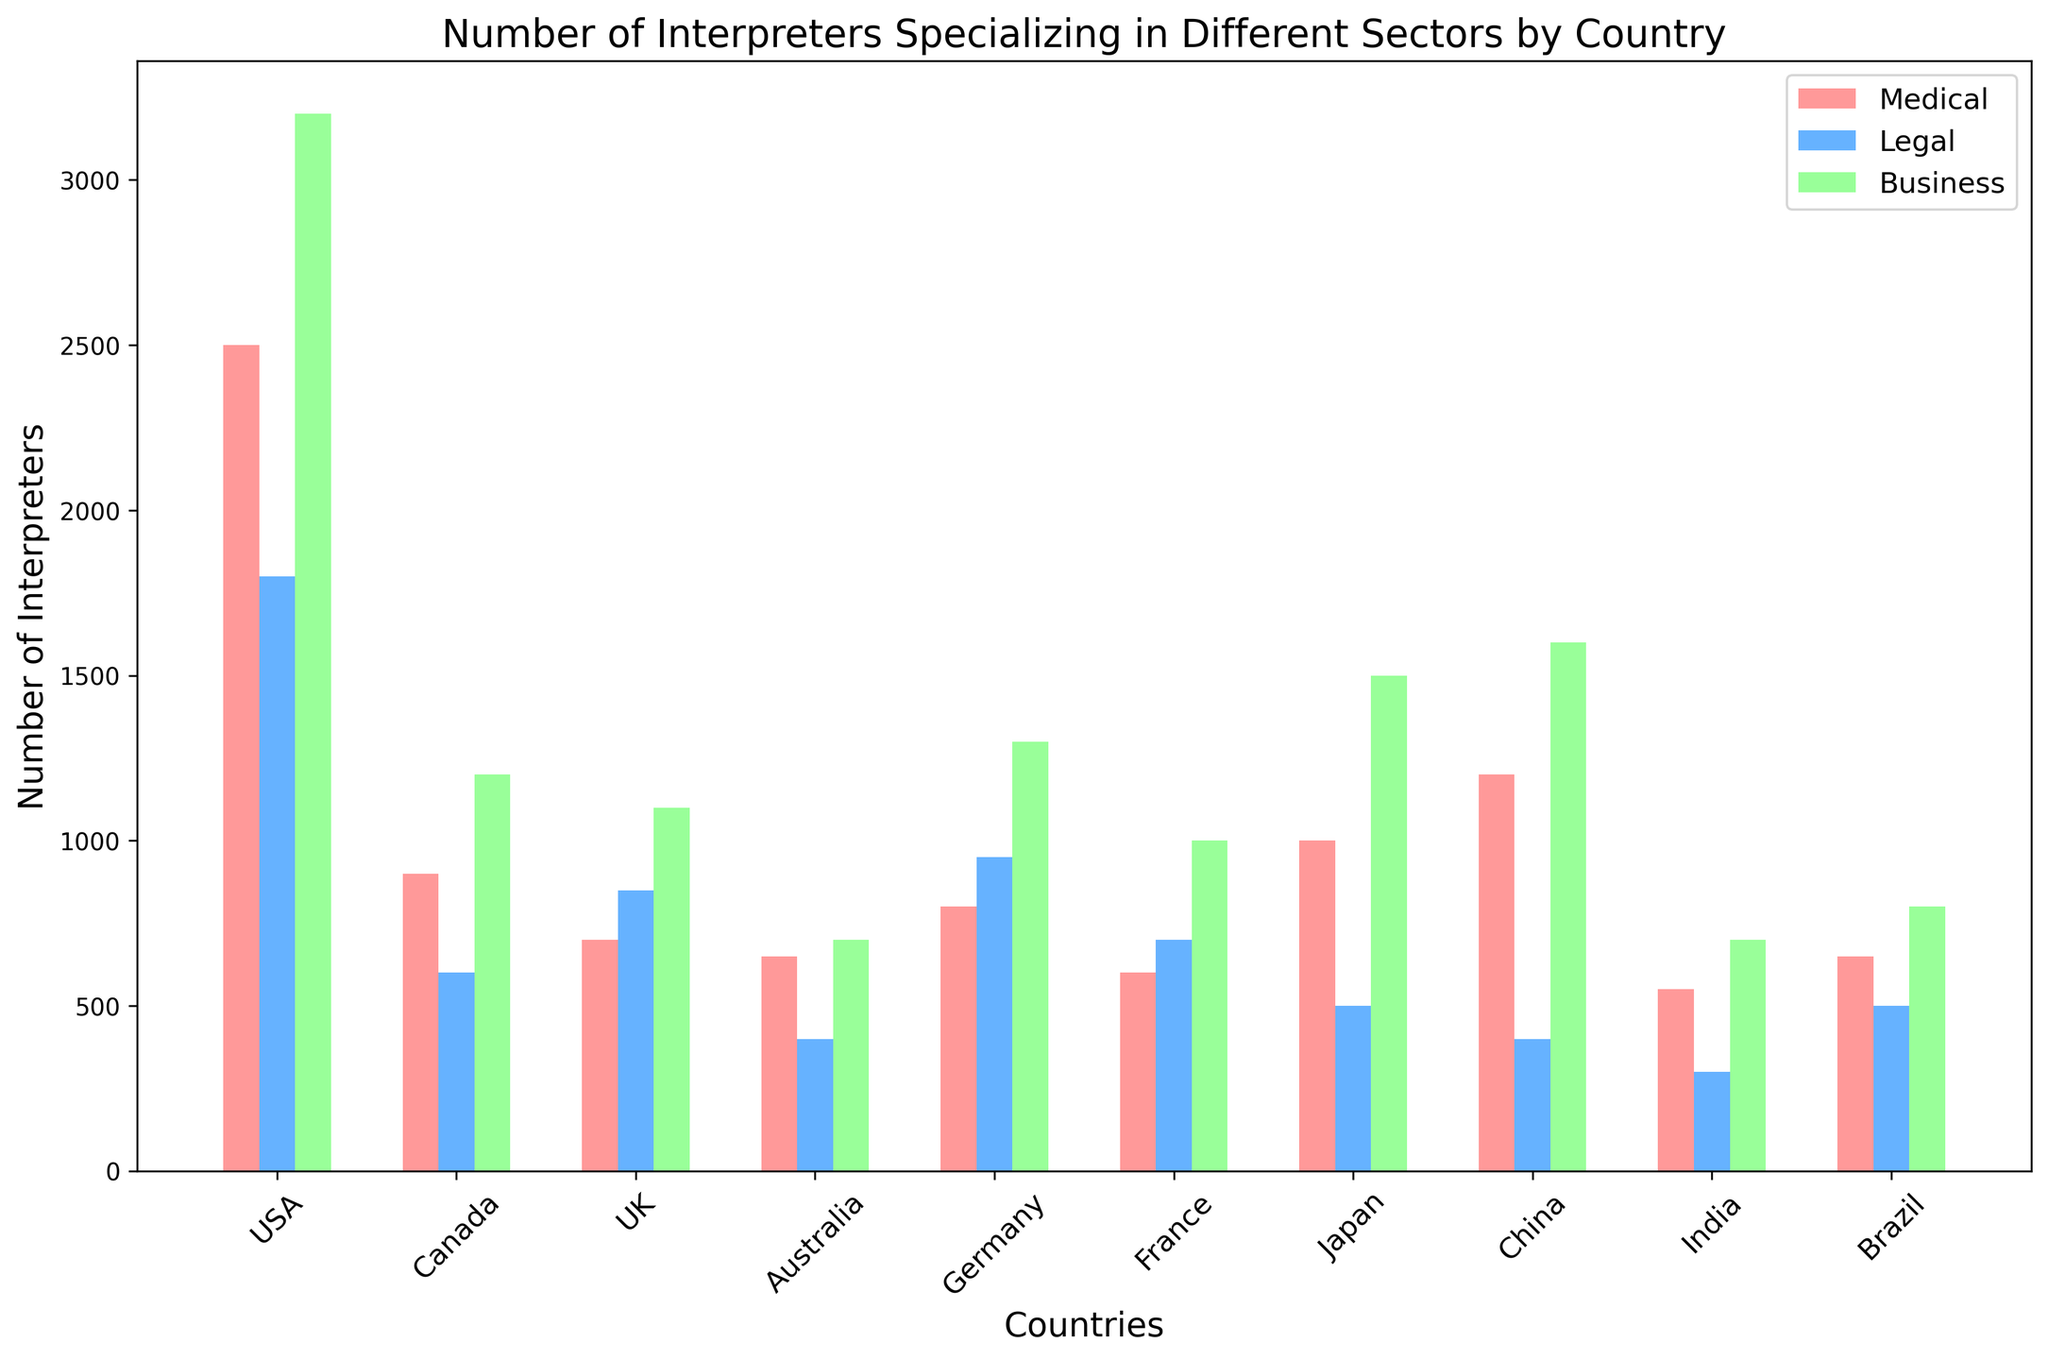What country has the highest number of business interpreters? From the chart, we see that the USA has the tallest bar in the Business category, indicating the highest number.
Answer: USA Which country has the smallest number of medical interpreters? From the chart, India has the shortest bar in the Medical category.
Answer: India What is the total number of interpreters in the UK across all sectors? Summing up the number of interpreters in the UK for Medical (700), Legal (850), and Business (1100) sectors, we get 700 + 850 + 1100 = 2650.
Answer: 2650 Which country has more legal interpreters: Germany or Japan? Comparing the heights of the bars in the Legal category for Germany and Japan, we see that Germany has a higher bar.
Answer: Germany How many countries have more than 1000 business interpreters? The chart shows that the USA, China, and Japan have bars exceeding 1000 in the Business category. Counting these, we get 3 countries.
Answer: 3 What is the average number of legal interpreters in Australia and Brazil? Summing up the number of legal interpreters in Australia (400) and Brazil (500), we get 400 + 500 = 900. Dividing by 2, the average is 900 / 2 = 450.
Answer: 450 Which country has the highest total number of interpreters across all sectors? Summing up the number of interpreters for all sectors, the USA has Medical (2500) + Legal (1800) + Business (3200) = 7500, which is higher than any other country.
Answer: USA Compare the number of medical interpreters between Canada and the UK. Which has more, and by how much? Canada has 900 medical interpreters, and the UK has 700. The difference is 900 - 700 = 200. So, Canada has 200 more medical interpreters.
Answer: Canada, 200 Which sector (Medical, Legal, Business) has the most interpreters in Germany? By comparing the heights of the bars for Germany, the Business sector has the tallest bar, indicating the highest number.
Answer: Business What is the difference in the number of business interpreters between France and Australia? France has 1000 business interpreters, and Australia has 700. The difference is 1000 - 700 = 300.
Answer: 300 